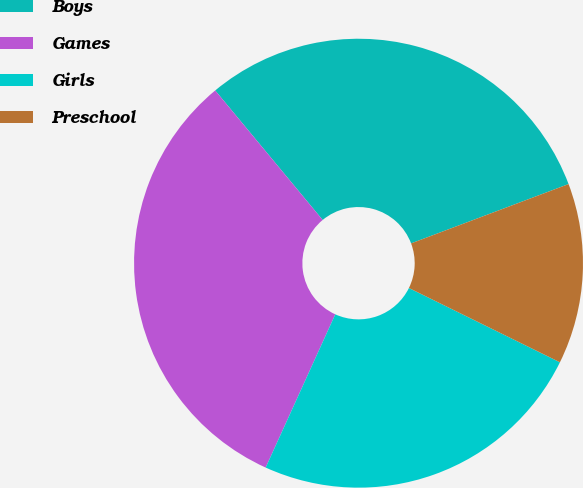<chart> <loc_0><loc_0><loc_500><loc_500><pie_chart><fcel>Boys<fcel>Games<fcel>Girls<fcel>Preschool<nl><fcel>30.29%<fcel>32.19%<fcel>24.51%<fcel>13.01%<nl></chart> 